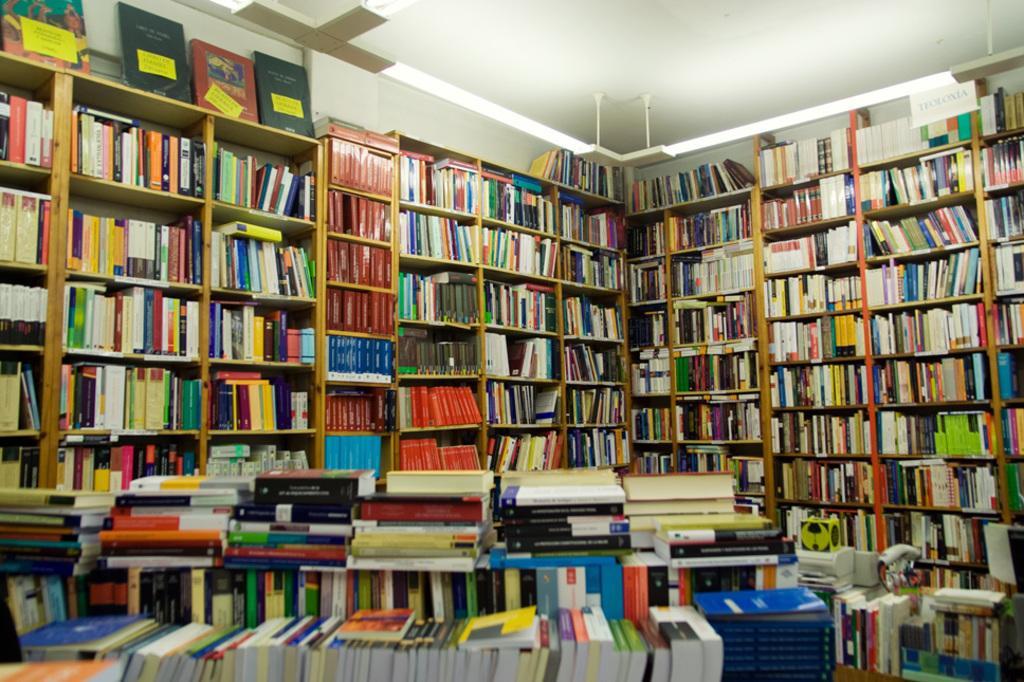How would you summarize this image in a sentence or two? This is an inside view of a room. It seems to be a library. At the bottom there are many books. In the background there are many racks filled with the books. At the top of the image I can see the roof. 